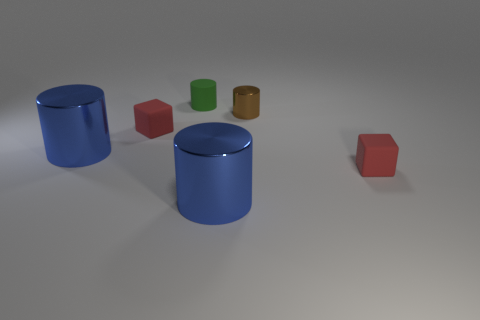Subtract all red blocks. How many blue cylinders are left? 2 Subtract all metallic cylinders. How many cylinders are left? 1 Subtract 2 cylinders. How many cylinders are left? 2 Add 3 tiny brown things. How many objects exist? 9 Subtract all blue cylinders. How many cylinders are left? 2 Subtract all cylinders. How many objects are left? 2 Subtract all brown cylinders. Subtract all blue blocks. How many cylinders are left? 3 Subtract all green cylinders. Subtract all tiny red rubber things. How many objects are left? 3 Add 2 blue metal objects. How many blue metal objects are left? 4 Add 2 small matte cubes. How many small matte cubes exist? 4 